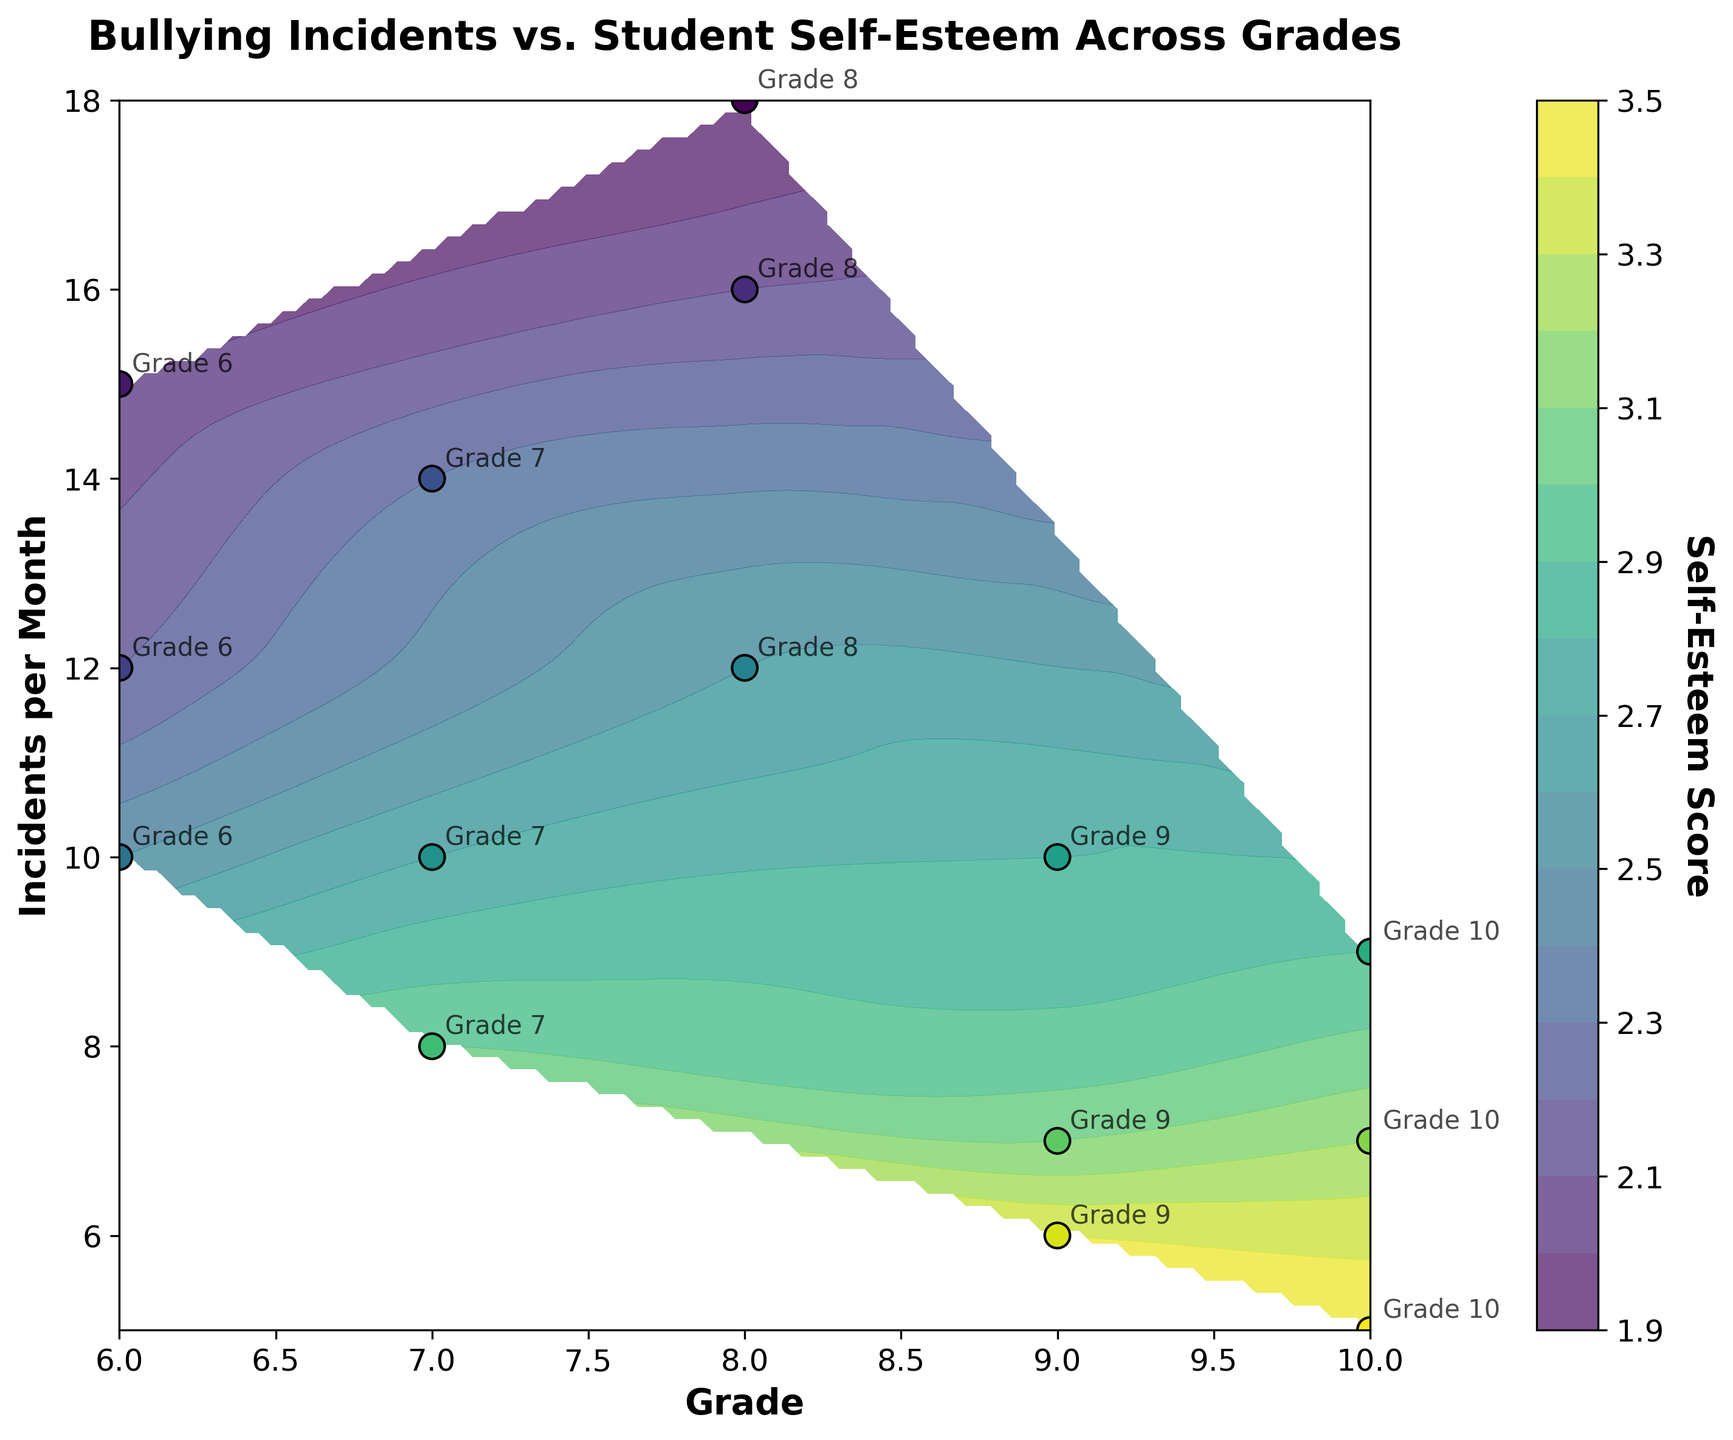what is the title of the figure? The title is usually located at the top of the figure. Here, it says "Bullying Incidents vs. Student Self-Esteem Across Grades."
Answer: Bullying Incidents vs. Student Self-Esteem Across Grades What do the x and y-axis represent? The x-axis represents the grade levels, and the y-axis represents the number of bullying incidents per month. This information can be found from the axis labels.
Answer: Grade levels and incidents per month What does the color bar represent? The color bar indicates the self-esteem scores of students. Darker colors usually represent lower self-esteem, whereas lighter colors represent higher self-esteem. This information is derived from the color bar label.
Answer: Self-Esteem Score Are there more bullying incidents in grade 8 compared to grade 9? By observing the scatter plot points, grade 8 shows incidents generally around 12 to 18 per month while grade 9 shows incidents from 6 to 10 per month. Therefore, grade 8 has higher incidents.
Answer: Yes Which grade has the highest self-esteem score, and what value is it closest to? Observing the color gradient, the lightest point (highest self-esteem) is in grade 10, with a value closest to 3.5.
Answer: Grade 10, value is 3.5 How does self-esteem generally change between grades 6 and 10? By following the color progression from grade 6 to grade 10, we see that darker colors in earlier grades transition to lighter colors in later grades. This indicates that self-esteem generally increases from grade 6 to grade 10.
Answer: Increases In grade 7, what is the range of bullying incidents, and how do self-esteem scores vary across this range? By looking at the points and the color, grade 7 has incidents ranging from 8 to 14 per month, and the self-esteem scores, indicated by the colors, range from around 2.3 to 3.0.
Answer: Incidents: 8-14, Self-esteem: 2.3-3.0 Is there a visible correlation between the number of bullying incidents and self-esteem scores? Higher incidents are generally represented with darker colors (lower self-esteem) and lower incidents with lighter colors (higher self-esteem). This suggests a negative correlation.
Answer: Negative correlation What is the general trend in bullying incidents from grades 6 to 10? The number of incidents per month appears to decrease as we move from grade 6 to grade 10. This can be seen as points in earlier grades (left side) are higher on the y-axis, while those in later grades (right side) are lower.
Answer: Decrease 